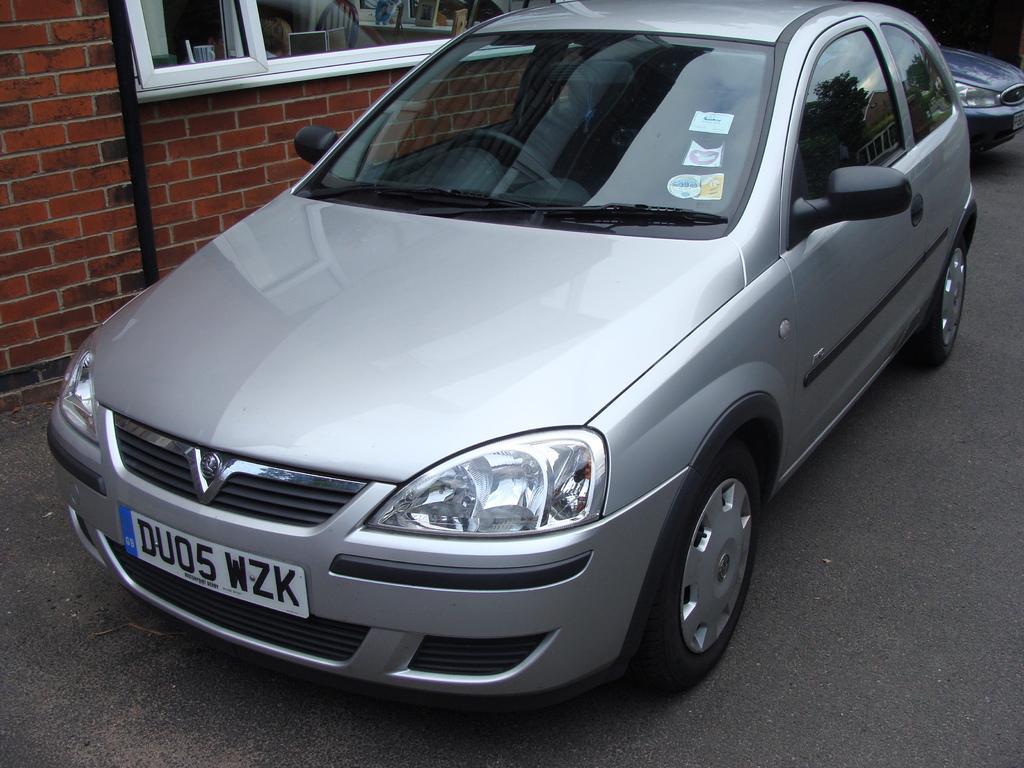How would you summarize this image in a sentence or two? In the middle of the image, there is a gray color vehicle on the road. Beside this vehicle, there is a building, there is a building having glass window and a brick wall. In the background, there is a vehicle on the road. 